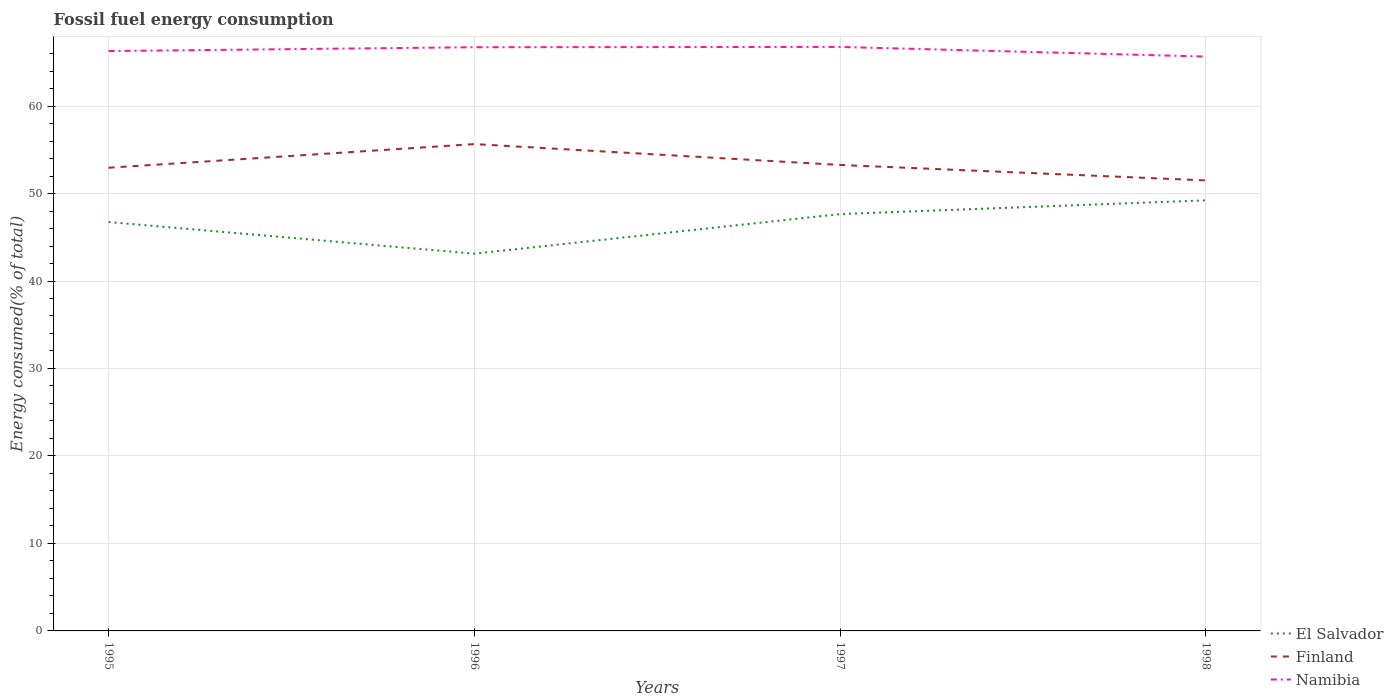How many different coloured lines are there?
Provide a succinct answer. 3. Is the number of lines equal to the number of legend labels?
Your answer should be compact. Yes. Across all years, what is the maximum percentage of energy consumed in El Salvador?
Ensure brevity in your answer.  43.13. What is the total percentage of energy consumed in Finland in the graph?
Ensure brevity in your answer.  -2.71. What is the difference between the highest and the second highest percentage of energy consumed in El Salvador?
Your answer should be very brief. 6.1. Is the percentage of energy consumed in El Salvador strictly greater than the percentage of energy consumed in Namibia over the years?
Provide a short and direct response. Yes. How many years are there in the graph?
Offer a very short reply. 4. Does the graph contain any zero values?
Your response must be concise. No. Does the graph contain grids?
Your answer should be very brief. Yes. Where does the legend appear in the graph?
Your answer should be very brief. Bottom right. What is the title of the graph?
Offer a very short reply. Fossil fuel energy consumption. What is the label or title of the X-axis?
Your response must be concise. Years. What is the label or title of the Y-axis?
Ensure brevity in your answer.  Energy consumed(% of total). What is the Energy consumed(% of total) of El Salvador in 1995?
Offer a terse response. 46.74. What is the Energy consumed(% of total) of Finland in 1995?
Provide a succinct answer. 52.95. What is the Energy consumed(% of total) in Namibia in 1995?
Offer a very short reply. 66.29. What is the Energy consumed(% of total) of El Salvador in 1996?
Make the answer very short. 43.13. What is the Energy consumed(% of total) in Finland in 1996?
Offer a terse response. 55.65. What is the Energy consumed(% of total) in Namibia in 1996?
Make the answer very short. 66.73. What is the Energy consumed(% of total) of El Salvador in 1997?
Offer a terse response. 47.65. What is the Energy consumed(% of total) in Finland in 1997?
Keep it short and to the point. 53.27. What is the Energy consumed(% of total) in Namibia in 1997?
Offer a terse response. 66.76. What is the Energy consumed(% of total) of El Salvador in 1998?
Provide a succinct answer. 49.22. What is the Energy consumed(% of total) in Finland in 1998?
Make the answer very short. 51.5. What is the Energy consumed(% of total) in Namibia in 1998?
Provide a succinct answer. 65.66. Across all years, what is the maximum Energy consumed(% of total) of El Salvador?
Keep it short and to the point. 49.22. Across all years, what is the maximum Energy consumed(% of total) of Finland?
Provide a short and direct response. 55.65. Across all years, what is the maximum Energy consumed(% of total) in Namibia?
Offer a terse response. 66.76. Across all years, what is the minimum Energy consumed(% of total) of El Salvador?
Provide a short and direct response. 43.13. Across all years, what is the minimum Energy consumed(% of total) in Finland?
Offer a very short reply. 51.5. Across all years, what is the minimum Energy consumed(% of total) in Namibia?
Give a very brief answer. 65.66. What is the total Energy consumed(% of total) in El Salvador in the graph?
Ensure brevity in your answer.  186.74. What is the total Energy consumed(% of total) of Finland in the graph?
Provide a succinct answer. 213.36. What is the total Energy consumed(% of total) in Namibia in the graph?
Your answer should be compact. 265.43. What is the difference between the Energy consumed(% of total) in El Salvador in 1995 and that in 1996?
Your answer should be compact. 3.62. What is the difference between the Energy consumed(% of total) in Finland in 1995 and that in 1996?
Provide a short and direct response. -2.71. What is the difference between the Energy consumed(% of total) of Namibia in 1995 and that in 1996?
Offer a very short reply. -0.44. What is the difference between the Energy consumed(% of total) of El Salvador in 1995 and that in 1997?
Ensure brevity in your answer.  -0.91. What is the difference between the Energy consumed(% of total) of Finland in 1995 and that in 1997?
Make the answer very short. -0.32. What is the difference between the Energy consumed(% of total) of Namibia in 1995 and that in 1997?
Your response must be concise. -0.47. What is the difference between the Energy consumed(% of total) of El Salvador in 1995 and that in 1998?
Your response must be concise. -2.48. What is the difference between the Energy consumed(% of total) of Finland in 1995 and that in 1998?
Make the answer very short. 1.45. What is the difference between the Energy consumed(% of total) of Namibia in 1995 and that in 1998?
Offer a terse response. 0.63. What is the difference between the Energy consumed(% of total) of El Salvador in 1996 and that in 1997?
Offer a very short reply. -4.53. What is the difference between the Energy consumed(% of total) of Finland in 1996 and that in 1997?
Make the answer very short. 2.39. What is the difference between the Energy consumed(% of total) of Namibia in 1996 and that in 1997?
Provide a short and direct response. -0.03. What is the difference between the Energy consumed(% of total) in El Salvador in 1996 and that in 1998?
Offer a very short reply. -6.1. What is the difference between the Energy consumed(% of total) in Finland in 1996 and that in 1998?
Provide a succinct answer. 4.15. What is the difference between the Energy consumed(% of total) in Namibia in 1996 and that in 1998?
Keep it short and to the point. 1.07. What is the difference between the Energy consumed(% of total) in El Salvador in 1997 and that in 1998?
Your answer should be very brief. -1.57. What is the difference between the Energy consumed(% of total) of Finland in 1997 and that in 1998?
Ensure brevity in your answer.  1.77. What is the difference between the Energy consumed(% of total) in Namibia in 1997 and that in 1998?
Your answer should be very brief. 1.1. What is the difference between the Energy consumed(% of total) of El Salvador in 1995 and the Energy consumed(% of total) of Finland in 1996?
Your response must be concise. -8.91. What is the difference between the Energy consumed(% of total) in El Salvador in 1995 and the Energy consumed(% of total) in Namibia in 1996?
Your answer should be very brief. -19.99. What is the difference between the Energy consumed(% of total) in Finland in 1995 and the Energy consumed(% of total) in Namibia in 1996?
Provide a succinct answer. -13.78. What is the difference between the Energy consumed(% of total) of El Salvador in 1995 and the Energy consumed(% of total) of Finland in 1997?
Your answer should be compact. -6.52. What is the difference between the Energy consumed(% of total) of El Salvador in 1995 and the Energy consumed(% of total) of Namibia in 1997?
Give a very brief answer. -20.02. What is the difference between the Energy consumed(% of total) in Finland in 1995 and the Energy consumed(% of total) in Namibia in 1997?
Provide a succinct answer. -13.81. What is the difference between the Energy consumed(% of total) of El Salvador in 1995 and the Energy consumed(% of total) of Finland in 1998?
Provide a succinct answer. -4.76. What is the difference between the Energy consumed(% of total) in El Salvador in 1995 and the Energy consumed(% of total) in Namibia in 1998?
Provide a succinct answer. -18.91. What is the difference between the Energy consumed(% of total) in Finland in 1995 and the Energy consumed(% of total) in Namibia in 1998?
Keep it short and to the point. -12.71. What is the difference between the Energy consumed(% of total) in El Salvador in 1996 and the Energy consumed(% of total) in Finland in 1997?
Provide a succinct answer. -10.14. What is the difference between the Energy consumed(% of total) of El Salvador in 1996 and the Energy consumed(% of total) of Namibia in 1997?
Your response must be concise. -23.63. What is the difference between the Energy consumed(% of total) in Finland in 1996 and the Energy consumed(% of total) in Namibia in 1997?
Offer a very short reply. -11.11. What is the difference between the Energy consumed(% of total) in El Salvador in 1996 and the Energy consumed(% of total) in Finland in 1998?
Keep it short and to the point. -8.37. What is the difference between the Energy consumed(% of total) of El Salvador in 1996 and the Energy consumed(% of total) of Namibia in 1998?
Keep it short and to the point. -22.53. What is the difference between the Energy consumed(% of total) in Finland in 1996 and the Energy consumed(% of total) in Namibia in 1998?
Your response must be concise. -10. What is the difference between the Energy consumed(% of total) of El Salvador in 1997 and the Energy consumed(% of total) of Finland in 1998?
Your response must be concise. -3.84. What is the difference between the Energy consumed(% of total) of El Salvador in 1997 and the Energy consumed(% of total) of Namibia in 1998?
Your answer should be very brief. -18. What is the difference between the Energy consumed(% of total) in Finland in 1997 and the Energy consumed(% of total) in Namibia in 1998?
Your answer should be very brief. -12.39. What is the average Energy consumed(% of total) in El Salvador per year?
Keep it short and to the point. 46.69. What is the average Energy consumed(% of total) in Finland per year?
Provide a short and direct response. 53.34. What is the average Energy consumed(% of total) of Namibia per year?
Ensure brevity in your answer.  66.36. In the year 1995, what is the difference between the Energy consumed(% of total) in El Salvador and Energy consumed(% of total) in Finland?
Your answer should be very brief. -6.21. In the year 1995, what is the difference between the Energy consumed(% of total) of El Salvador and Energy consumed(% of total) of Namibia?
Give a very brief answer. -19.55. In the year 1995, what is the difference between the Energy consumed(% of total) in Finland and Energy consumed(% of total) in Namibia?
Provide a succinct answer. -13.34. In the year 1996, what is the difference between the Energy consumed(% of total) of El Salvador and Energy consumed(% of total) of Finland?
Keep it short and to the point. -12.53. In the year 1996, what is the difference between the Energy consumed(% of total) of El Salvador and Energy consumed(% of total) of Namibia?
Provide a succinct answer. -23.6. In the year 1996, what is the difference between the Energy consumed(% of total) of Finland and Energy consumed(% of total) of Namibia?
Offer a terse response. -11.07. In the year 1997, what is the difference between the Energy consumed(% of total) of El Salvador and Energy consumed(% of total) of Finland?
Ensure brevity in your answer.  -5.61. In the year 1997, what is the difference between the Energy consumed(% of total) in El Salvador and Energy consumed(% of total) in Namibia?
Your answer should be very brief. -19.11. In the year 1997, what is the difference between the Energy consumed(% of total) of Finland and Energy consumed(% of total) of Namibia?
Ensure brevity in your answer.  -13.49. In the year 1998, what is the difference between the Energy consumed(% of total) of El Salvador and Energy consumed(% of total) of Finland?
Provide a succinct answer. -2.27. In the year 1998, what is the difference between the Energy consumed(% of total) of El Salvador and Energy consumed(% of total) of Namibia?
Your response must be concise. -16.43. In the year 1998, what is the difference between the Energy consumed(% of total) in Finland and Energy consumed(% of total) in Namibia?
Provide a short and direct response. -14.16. What is the ratio of the Energy consumed(% of total) in El Salvador in 1995 to that in 1996?
Make the answer very short. 1.08. What is the ratio of the Energy consumed(% of total) of Finland in 1995 to that in 1996?
Your answer should be compact. 0.95. What is the ratio of the Energy consumed(% of total) in El Salvador in 1995 to that in 1997?
Provide a short and direct response. 0.98. What is the ratio of the Energy consumed(% of total) in El Salvador in 1995 to that in 1998?
Your answer should be very brief. 0.95. What is the ratio of the Energy consumed(% of total) in Finland in 1995 to that in 1998?
Offer a very short reply. 1.03. What is the ratio of the Energy consumed(% of total) of Namibia in 1995 to that in 1998?
Give a very brief answer. 1.01. What is the ratio of the Energy consumed(% of total) of El Salvador in 1996 to that in 1997?
Make the answer very short. 0.91. What is the ratio of the Energy consumed(% of total) of Finland in 1996 to that in 1997?
Provide a succinct answer. 1.04. What is the ratio of the Energy consumed(% of total) of Namibia in 1996 to that in 1997?
Offer a very short reply. 1. What is the ratio of the Energy consumed(% of total) in El Salvador in 1996 to that in 1998?
Offer a terse response. 0.88. What is the ratio of the Energy consumed(% of total) of Finland in 1996 to that in 1998?
Your answer should be very brief. 1.08. What is the ratio of the Energy consumed(% of total) in Namibia in 1996 to that in 1998?
Offer a very short reply. 1.02. What is the ratio of the Energy consumed(% of total) in El Salvador in 1997 to that in 1998?
Your answer should be compact. 0.97. What is the ratio of the Energy consumed(% of total) in Finland in 1997 to that in 1998?
Provide a short and direct response. 1.03. What is the ratio of the Energy consumed(% of total) in Namibia in 1997 to that in 1998?
Give a very brief answer. 1.02. What is the difference between the highest and the second highest Energy consumed(% of total) of El Salvador?
Keep it short and to the point. 1.57. What is the difference between the highest and the second highest Energy consumed(% of total) of Finland?
Your answer should be compact. 2.39. What is the difference between the highest and the second highest Energy consumed(% of total) of Namibia?
Provide a succinct answer. 0.03. What is the difference between the highest and the lowest Energy consumed(% of total) of El Salvador?
Offer a terse response. 6.1. What is the difference between the highest and the lowest Energy consumed(% of total) in Finland?
Your answer should be compact. 4.15. What is the difference between the highest and the lowest Energy consumed(% of total) in Namibia?
Offer a very short reply. 1.1. 